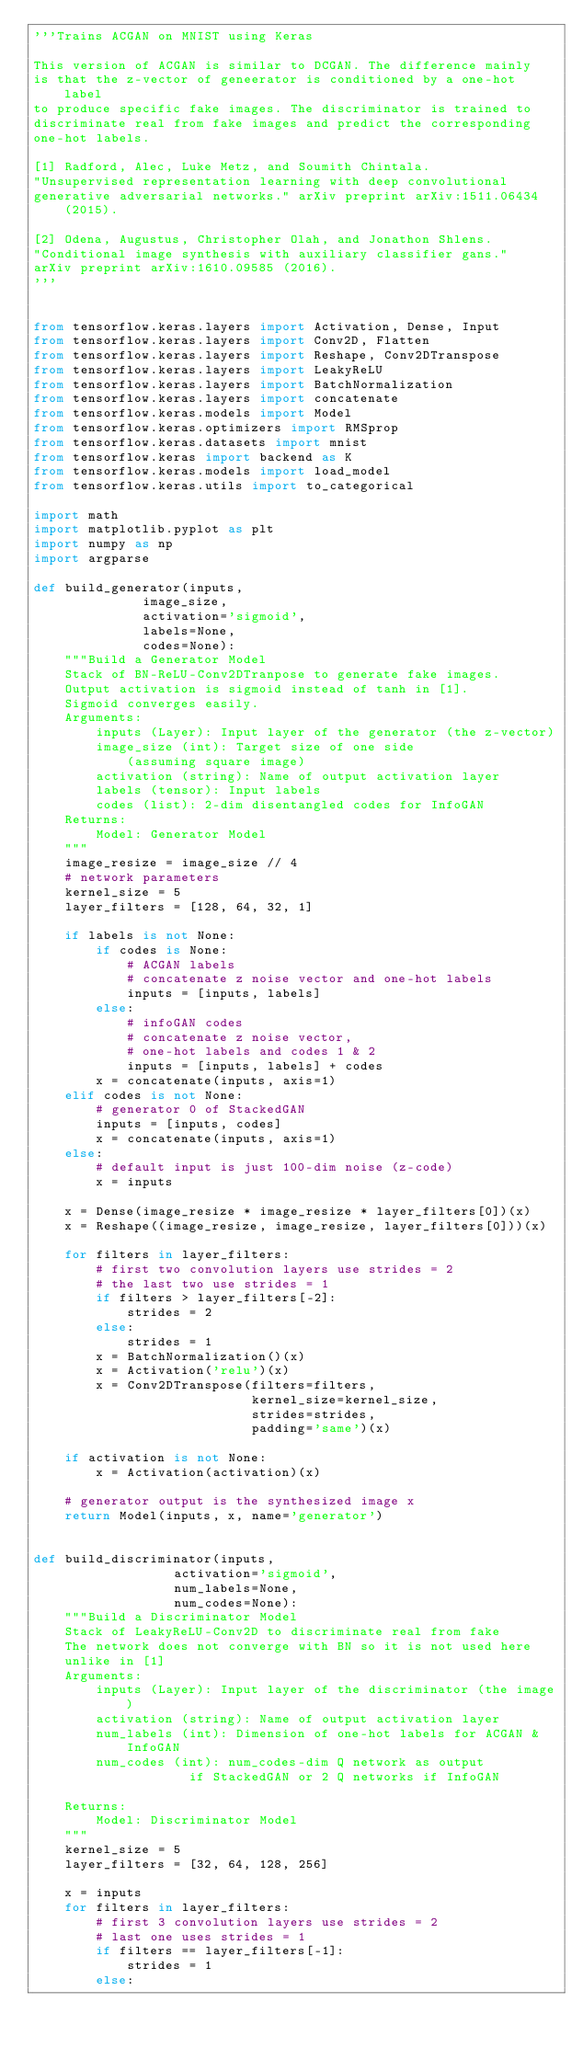<code> <loc_0><loc_0><loc_500><loc_500><_Python_>'''Trains ACGAN on MNIST using Keras

This version of ACGAN is similar to DCGAN. The difference mainly
is that the z-vector of geneerator is conditioned by a one-hot label
to produce specific fake images. The discriminator is trained to
discriminate real from fake images and predict the corresponding
one-hot labels.

[1] Radford, Alec, Luke Metz, and Soumith Chintala.
"Unsupervised representation learning with deep convolutional
generative adversarial networks." arXiv preprint arXiv:1511.06434 (2015).

[2] Odena, Augustus, Christopher Olah, and Jonathon Shlens.
"Conditional image synthesis with auxiliary classifier gans."
arXiv preprint arXiv:1610.09585 (2016).
'''


from tensorflow.keras.layers import Activation, Dense, Input
from tensorflow.keras.layers import Conv2D, Flatten
from tensorflow.keras.layers import Reshape, Conv2DTranspose
from tensorflow.keras.layers import LeakyReLU
from tensorflow.keras.layers import BatchNormalization
from tensorflow.keras.layers import concatenate
from tensorflow.keras.models import Model
from tensorflow.keras.optimizers import RMSprop
from tensorflow.keras.datasets import mnist
from tensorflow.keras import backend as K
from tensorflow.keras.models import load_model
from tensorflow.keras.utils import to_categorical

import math
import matplotlib.pyplot as plt
import numpy as np
import argparse

def build_generator(inputs,
              image_size,
              activation='sigmoid',
              labels=None,
              codes=None):
    """Build a Generator Model
    Stack of BN-ReLU-Conv2DTranpose to generate fake images.
    Output activation is sigmoid instead of tanh in [1].
    Sigmoid converges easily.
    Arguments:
        inputs (Layer): Input layer of the generator (the z-vector)
        image_size (int): Target size of one side
            (assuming square image)
        activation (string): Name of output activation layer
        labels (tensor): Input labels
        codes (list): 2-dim disentangled codes for InfoGAN
    Returns:
        Model: Generator Model
    """
    image_resize = image_size // 4
    # network parameters
    kernel_size = 5
    layer_filters = [128, 64, 32, 1]

    if labels is not None:
        if codes is None:
            # ACGAN labels
            # concatenate z noise vector and one-hot labels
            inputs = [inputs, labels]
        else:
            # infoGAN codes
            # concatenate z noise vector,
            # one-hot labels and codes 1 & 2
            inputs = [inputs, labels] + codes
        x = concatenate(inputs, axis=1)
    elif codes is not None:
        # generator 0 of StackedGAN
        inputs = [inputs, codes]
        x = concatenate(inputs, axis=1)
    else:
        # default input is just 100-dim noise (z-code)
        x = inputs

    x = Dense(image_resize * image_resize * layer_filters[0])(x)
    x = Reshape((image_resize, image_resize, layer_filters[0]))(x)

    for filters in layer_filters:
        # first two convolution layers use strides = 2
        # the last two use strides = 1
        if filters > layer_filters[-2]:
            strides = 2
        else:
            strides = 1
        x = BatchNormalization()(x)
        x = Activation('relu')(x)
        x = Conv2DTranspose(filters=filters,
                            kernel_size=kernel_size,
                            strides=strides,
                            padding='same')(x)

    if activation is not None:
        x = Activation(activation)(x)

    # generator output is the synthesized image x
    return Model(inputs, x, name='generator')


def build_discriminator(inputs,
                  activation='sigmoid',
                  num_labels=None,
                  num_codes=None):
    """Build a Discriminator Model
    Stack of LeakyReLU-Conv2D to discriminate real from fake
    The network does not converge with BN so it is not used here
    unlike in [1]
    Arguments:
        inputs (Layer): Input layer of the discriminator (the image)
        activation (string): Name of output activation layer
        num_labels (int): Dimension of one-hot labels for ACGAN & InfoGAN
        num_codes (int): num_codes-dim Q network as output
                    if StackedGAN or 2 Q networks if InfoGAN

    Returns:
        Model: Discriminator Model
    """
    kernel_size = 5
    layer_filters = [32, 64, 128, 256]

    x = inputs
    for filters in layer_filters:
        # first 3 convolution layers use strides = 2
        # last one uses strides = 1
        if filters == layer_filters[-1]:
            strides = 1
        else:</code> 